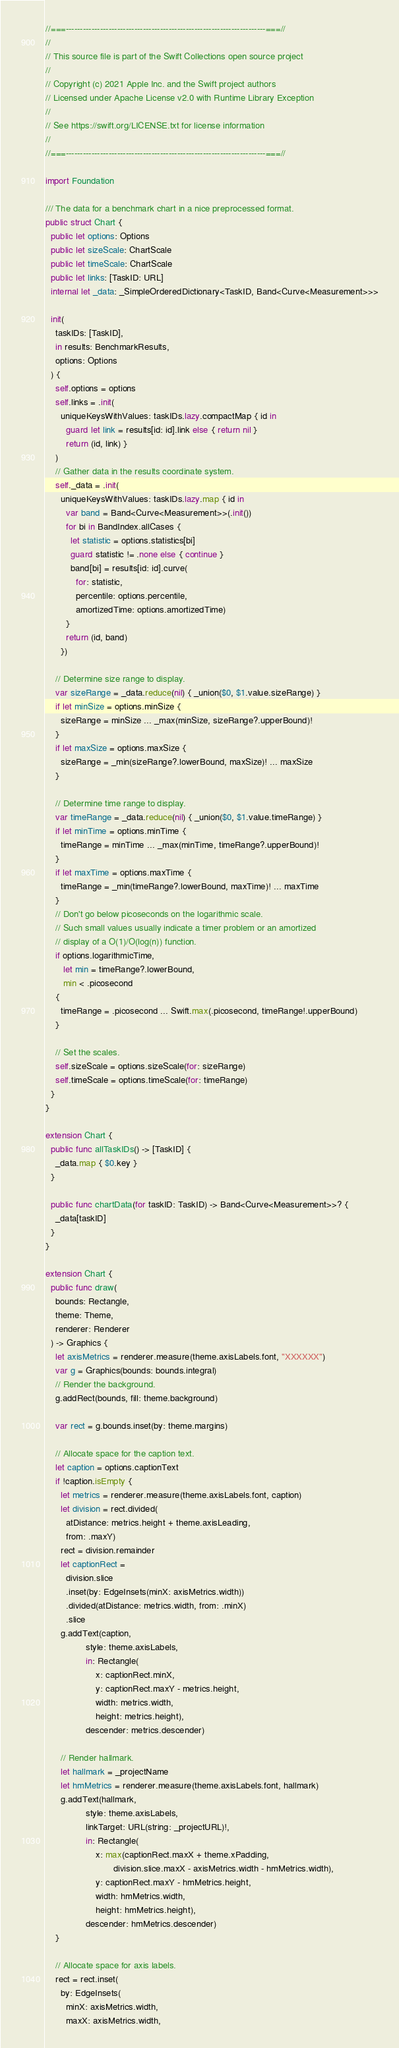<code> <loc_0><loc_0><loc_500><loc_500><_Swift_>//===----------------------------------------------------------------------===//
//
// This source file is part of the Swift Collections open source project
//
// Copyright (c) 2021 Apple Inc. and the Swift project authors
// Licensed under Apache License v2.0 with Runtime Library Exception
//
// See https://swift.org/LICENSE.txt for license information
//
//===----------------------------------------------------------------------===//

import Foundation

/// The data for a benchmark chart in a nice preprocessed format.
public struct Chart {
  public let options: Options
  public let sizeScale: ChartScale
  public let timeScale: ChartScale
  public let links: [TaskID: URL]
  internal let _data: _SimpleOrderedDictionary<TaskID, Band<Curve<Measurement>>>

  init(
    taskIDs: [TaskID],
    in results: BenchmarkResults,
    options: Options
  ) {
    self.options = options
    self.links = .init(
      uniqueKeysWithValues: taskIDs.lazy.compactMap { id in
        guard let link = results[id: id].link else { return nil }
        return (id, link) }
    )
    // Gather data in the results coordinate system.
    self._data = .init(
      uniqueKeysWithValues: taskIDs.lazy.map { id in
        var band = Band<Curve<Measurement>>(.init())
        for bi in BandIndex.allCases {
          let statistic = options.statistics[bi]
          guard statistic != .none else { continue }
          band[bi] = results[id: id].curve(
            for: statistic,
            percentile: options.percentile,
            amortizedTime: options.amortizedTime)
        }
        return (id, band)
      })

    // Determine size range to display.
    var sizeRange = _data.reduce(nil) { _union($0, $1.value.sizeRange) }
    if let minSize = options.minSize {
      sizeRange = minSize ... _max(minSize, sizeRange?.upperBound)!
    }
    if let maxSize = options.maxSize {
      sizeRange = _min(sizeRange?.lowerBound, maxSize)! ... maxSize
    }

    // Determine time range to display.
    var timeRange = _data.reduce(nil) { _union($0, $1.value.timeRange) }
    if let minTime = options.minTime {
      timeRange = minTime ... _max(minTime, timeRange?.upperBound)!
    }
    if let maxTime = options.maxTime {
      timeRange = _min(timeRange?.lowerBound, maxTime)! ... maxTime
    }
    // Don't go below picoseconds on the logarithmic scale.
    // Such small values usually indicate a timer problem or an amortized
    // display of a O(1)/O(log(n)) function.
    if options.logarithmicTime,
       let min = timeRange?.lowerBound,
       min < .picosecond
    {
      timeRange = .picosecond ... Swift.max(.picosecond, timeRange!.upperBound)
    }

    // Set the scales.
    self.sizeScale = options.sizeScale(for: sizeRange)
    self.timeScale = options.timeScale(for: timeRange)
  }
}

extension Chart {
  public func allTaskIDs() -> [TaskID] {
    _data.map { $0.key }
  }

  public func chartData(for taskID: TaskID) -> Band<Curve<Measurement>>? {
    _data[taskID]
  }
}

extension Chart {
  public func draw(
    bounds: Rectangle,
    theme: Theme,
    renderer: Renderer
  ) -> Graphics {
    let axisMetrics = renderer.measure(theme.axisLabels.font, "XXXXXX")
    var g = Graphics(bounds: bounds.integral)
    // Render the background.
    g.addRect(bounds, fill: theme.background)

    var rect = g.bounds.inset(by: theme.margins)

    // Allocate space for the caption text.
    let caption = options.captionText
    if !caption.isEmpty {
      let metrics = renderer.measure(theme.axisLabels.font, caption)
      let division = rect.divided(
        atDistance: metrics.height + theme.axisLeading,
        from: .maxY)
      rect = division.remainder
      let captionRect =
        division.slice
        .inset(by: EdgeInsets(minX: axisMetrics.width))
        .divided(atDistance: metrics.width, from: .minX)
        .slice
      g.addText(caption,
                style: theme.axisLabels,
                in: Rectangle(
                    x: captionRect.minX,
                    y: captionRect.maxY - metrics.height,
                    width: metrics.width,
                    height: metrics.height),
                descender: metrics.descender)

      // Render hallmark.
      let hallmark = _projectName
      let hmMetrics = renderer.measure(theme.axisLabels.font, hallmark)
      g.addText(hallmark,
                style: theme.axisLabels,
                linkTarget: URL(string: _projectURL)!,
                in: Rectangle(
                    x: max(captionRect.maxX + theme.xPadding,
                           division.slice.maxX - axisMetrics.width - hmMetrics.width),
                    y: captionRect.maxY - hmMetrics.height,
                    width: hmMetrics.width,
                    height: hmMetrics.height),
                descender: hmMetrics.descender)
    }

    // Allocate space for axis labels.
    rect = rect.inset(
      by: EdgeInsets(
        minX: axisMetrics.width,
        maxX: axisMetrics.width,</code> 